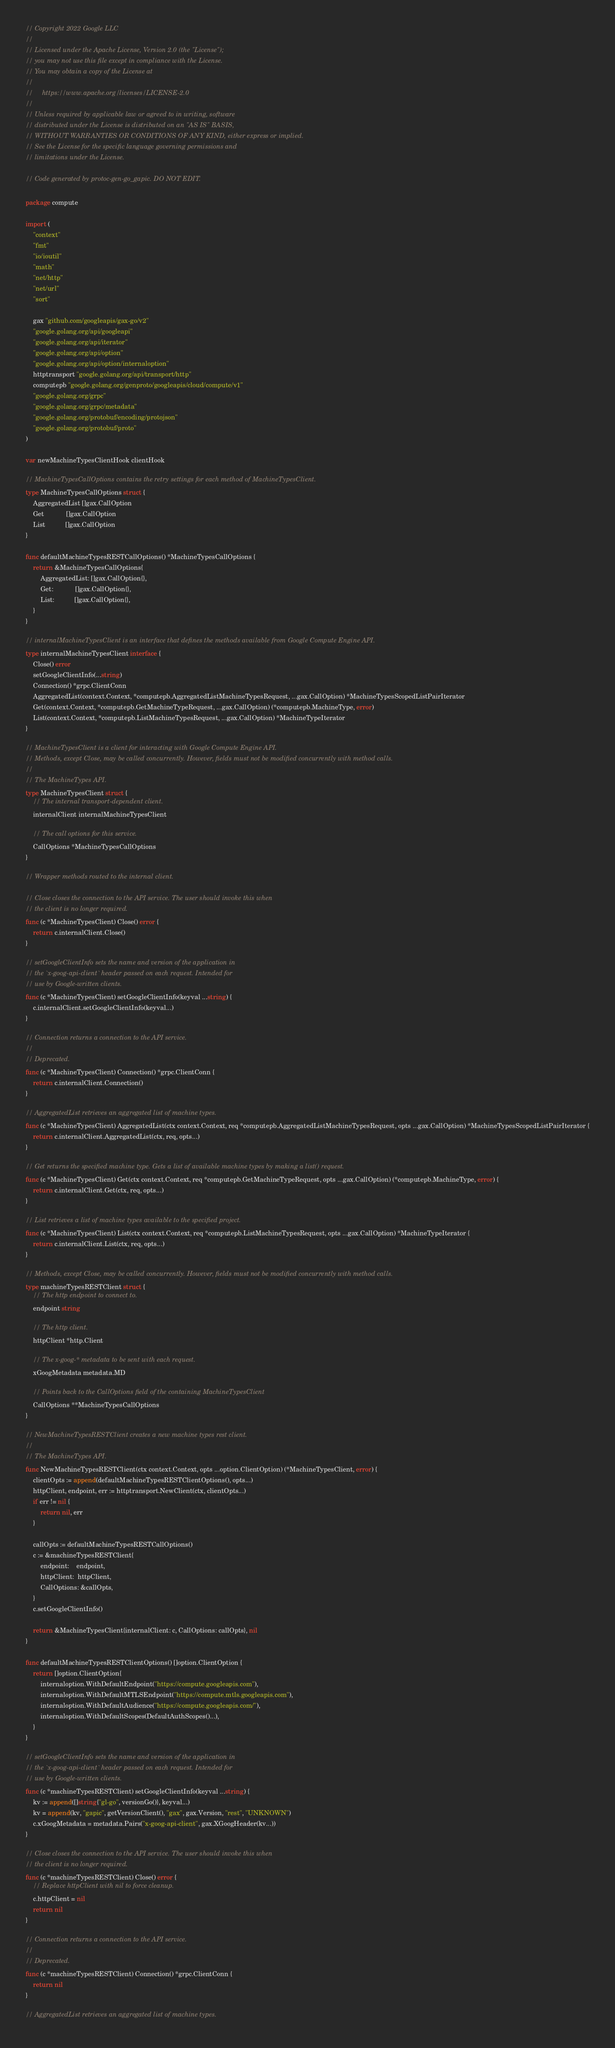<code> <loc_0><loc_0><loc_500><loc_500><_Go_>// Copyright 2022 Google LLC
//
// Licensed under the Apache License, Version 2.0 (the "License");
// you may not use this file except in compliance with the License.
// You may obtain a copy of the License at
//
//     https://www.apache.org/licenses/LICENSE-2.0
//
// Unless required by applicable law or agreed to in writing, software
// distributed under the License is distributed on an "AS IS" BASIS,
// WITHOUT WARRANTIES OR CONDITIONS OF ANY KIND, either express or implied.
// See the License for the specific language governing permissions and
// limitations under the License.

// Code generated by protoc-gen-go_gapic. DO NOT EDIT.

package compute

import (
	"context"
	"fmt"
	"io/ioutil"
	"math"
	"net/http"
	"net/url"
	"sort"

	gax "github.com/googleapis/gax-go/v2"
	"google.golang.org/api/googleapi"
	"google.golang.org/api/iterator"
	"google.golang.org/api/option"
	"google.golang.org/api/option/internaloption"
	httptransport "google.golang.org/api/transport/http"
	computepb "google.golang.org/genproto/googleapis/cloud/compute/v1"
	"google.golang.org/grpc"
	"google.golang.org/grpc/metadata"
	"google.golang.org/protobuf/encoding/protojson"
	"google.golang.org/protobuf/proto"
)

var newMachineTypesClientHook clientHook

// MachineTypesCallOptions contains the retry settings for each method of MachineTypesClient.
type MachineTypesCallOptions struct {
	AggregatedList []gax.CallOption
	Get            []gax.CallOption
	List           []gax.CallOption
}

func defaultMachineTypesRESTCallOptions() *MachineTypesCallOptions {
	return &MachineTypesCallOptions{
		AggregatedList: []gax.CallOption{},
		Get:            []gax.CallOption{},
		List:           []gax.CallOption{},
	}
}

// internalMachineTypesClient is an interface that defines the methods available from Google Compute Engine API.
type internalMachineTypesClient interface {
	Close() error
	setGoogleClientInfo(...string)
	Connection() *grpc.ClientConn
	AggregatedList(context.Context, *computepb.AggregatedListMachineTypesRequest, ...gax.CallOption) *MachineTypesScopedListPairIterator
	Get(context.Context, *computepb.GetMachineTypeRequest, ...gax.CallOption) (*computepb.MachineType, error)
	List(context.Context, *computepb.ListMachineTypesRequest, ...gax.CallOption) *MachineTypeIterator
}

// MachineTypesClient is a client for interacting with Google Compute Engine API.
// Methods, except Close, may be called concurrently. However, fields must not be modified concurrently with method calls.
//
// The MachineTypes API.
type MachineTypesClient struct {
	// The internal transport-dependent client.
	internalClient internalMachineTypesClient

	// The call options for this service.
	CallOptions *MachineTypesCallOptions
}

// Wrapper methods routed to the internal client.

// Close closes the connection to the API service. The user should invoke this when
// the client is no longer required.
func (c *MachineTypesClient) Close() error {
	return c.internalClient.Close()
}

// setGoogleClientInfo sets the name and version of the application in
// the `x-goog-api-client` header passed on each request. Intended for
// use by Google-written clients.
func (c *MachineTypesClient) setGoogleClientInfo(keyval ...string) {
	c.internalClient.setGoogleClientInfo(keyval...)
}

// Connection returns a connection to the API service.
//
// Deprecated.
func (c *MachineTypesClient) Connection() *grpc.ClientConn {
	return c.internalClient.Connection()
}

// AggregatedList retrieves an aggregated list of machine types.
func (c *MachineTypesClient) AggregatedList(ctx context.Context, req *computepb.AggregatedListMachineTypesRequest, opts ...gax.CallOption) *MachineTypesScopedListPairIterator {
	return c.internalClient.AggregatedList(ctx, req, opts...)
}

// Get returns the specified machine type. Gets a list of available machine types by making a list() request.
func (c *MachineTypesClient) Get(ctx context.Context, req *computepb.GetMachineTypeRequest, opts ...gax.CallOption) (*computepb.MachineType, error) {
	return c.internalClient.Get(ctx, req, opts...)
}

// List retrieves a list of machine types available to the specified project.
func (c *MachineTypesClient) List(ctx context.Context, req *computepb.ListMachineTypesRequest, opts ...gax.CallOption) *MachineTypeIterator {
	return c.internalClient.List(ctx, req, opts...)
}

// Methods, except Close, may be called concurrently. However, fields must not be modified concurrently with method calls.
type machineTypesRESTClient struct {
	// The http endpoint to connect to.
	endpoint string

	// The http client.
	httpClient *http.Client

	// The x-goog-* metadata to be sent with each request.
	xGoogMetadata metadata.MD

	// Points back to the CallOptions field of the containing MachineTypesClient
	CallOptions **MachineTypesCallOptions
}

// NewMachineTypesRESTClient creates a new machine types rest client.
//
// The MachineTypes API.
func NewMachineTypesRESTClient(ctx context.Context, opts ...option.ClientOption) (*MachineTypesClient, error) {
	clientOpts := append(defaultMachineTypesRESTClientOptions(), opts...)
	httpClient, endpoint, err := httptransport.NewClient(ctx, clientOpts...)
	if err != nil {
		return nil, err
	}

	callOpts := defaultMachineTypesRESTCallOptions()
	c := &machineTypesRESTClient{
		endpoint:    endpoint,
		httpClient:  httpClient,
		CallOptions: &callOpts,
	}
	c.setGoogleClientInfo()

	return &MachineTypesClient{internalClient: c, CallOptions: callOpts}, nil
}

func defaultMachineTypesRESTClientOptions() []option.ClientOption {
	return []option.ClientOption{
		internaloption.WithDefaultEndpoint("https://compute.googleapis.com"),
		internaloption.WithDefaultMTLSEndpoint("https://compute.mtls.googleapis.com"),
		internaloption.WithDefaultAudience("https://compute.googleapis.com/"),
		internaloption.WithDefaultScopes(DefaultAuthScopes()...),
	}
}

// setGoogleClientInfo sets the name and version of the application in
// the `x-goog-api-client` header passed on each request. Intended for
// use by Google-written clients.
func (c *machineTypesRESTClient) setGoogleClientInfo(keyval ...string) {
	kv := append([]string{"gl-go", versionGo()}, keyval...)
	kv = append(kv, "gapic", getVersionClient(), "gax", gax.Version, "rest", "UNKNOWN")
	c.xGoogMetadata = metadata.Pairs("x-goog-api-client", gax.XGoogHeader(kv...))
}

// Close closes the connection to the API service. The user should invoke this when
// the client is no longer required.
func (c *machineTypesRESTClient) Close() error {
	// Replace httpClient with nil to force cleanup.
	c.httpClient = nil
	return nil
}

// Connection returns a connection to the API service.
//
// Deprecated.
func (c *machineTypesRESTClient) Connection() *grpc.ClientConn {
	return nil
}

// AggregatedList retrieves an aggregated list of machine types.</code> 